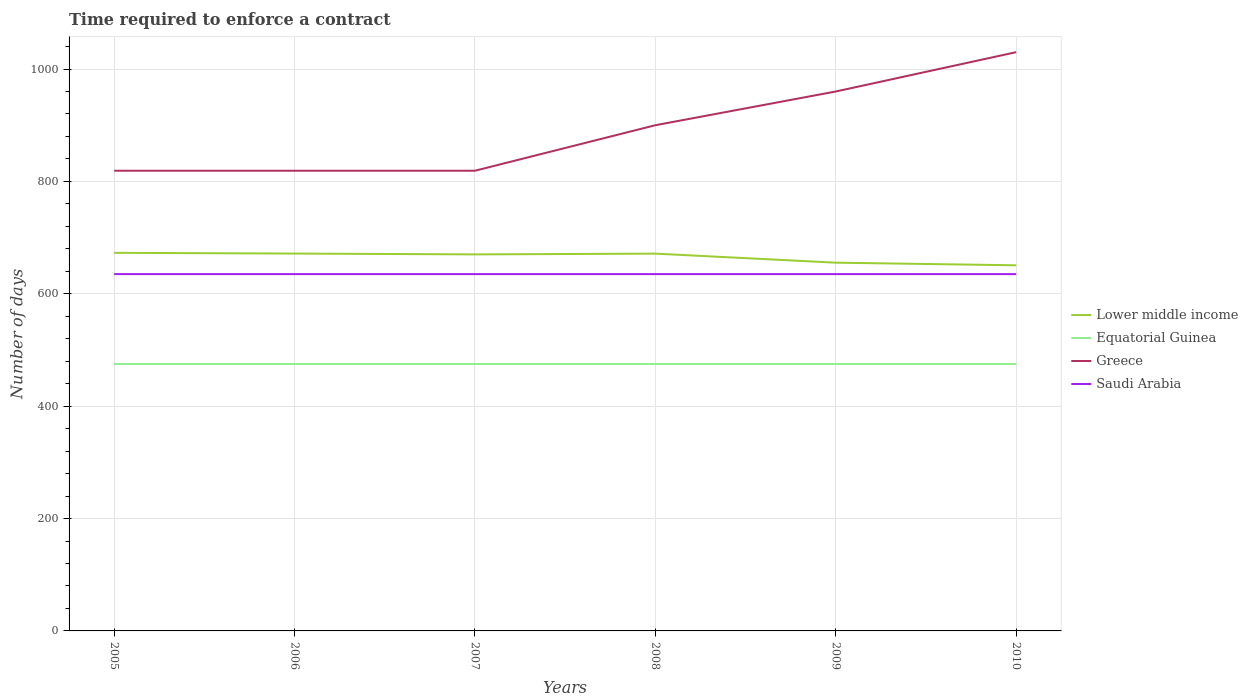Does the line corresponding to Equatorial Guinea intersect with the line corresponding to Lower middle income?
Your response must be concise. No. Is the number of lines equal to the number of legend labels?
Provide a succinct answer. Yes. Across all years, what is the maximum number of days required to enforce a contract in Saudi Arabia?
Ensure brevity in your answer.  635. In which year was the number of days required to enforce a contract in Saudi Arabia maximum?
Provide a short and direct response. 2005. What is the total number of days required to enforce a contract in Greece in the graph?
Your answer should be compact. -81. Is the number of days required to enforce a contract in Equatorial Guinea strictly greater than the number of days required to enforce a contract in Saudi Arabia over the years?
Offer a very short reply. Yes. How many lines are there?
Your answer should be very brief. 4. How many years are there in the graph?
Give a very brief answer. 6. Are the values on the major ticks of Y-axis written in scientific E-notation?
Your answer should be compact. No. Does the graph contain grids?
Provide a short and direct response. Yes. Where does the legend appear in the graph?
Make the answer very short. Center right. How many legend labels are there?
Ensure brevity in your answer.  4. How are the legend labels stacked?
Make the answer very short. Vertical. What is the title of the graph?
Your answer should be very brief. Time required to enforce a contract. What is the label or title of the Y-axis?
Give a very brief answer. Number of days. What is the Number of days of Lower middle income in 2005?
Provide a succinct answer. 672.89. What is the Number of days of Equatorial Guinea in 2005?
Keep it short and to the point. 475. What is the Number of days of Greece in 2005?
Your answer should be very brief. 819. What is the Number of days of Saudi Arabia in 2005?
Your answer should be compact. 635. What is the Number of days of Lower middle income in 2006?
Your answer should be compact. 671.59. What is the Number of days in Equatorial Guinea in 2006?
Offer a very short reply. 475. What is the Number of days in Greece in 2006?
Your response must be concise. 819. What is the Number of days in Saudi Arabia in 2006?
Offer a terse response. 635. What is the Number of days in Lower middle income in 2007?
Make the answer very short. 670.11. What is the Number of days in Equatorial Guinea in 2007?
Provide a succinct answer. 475. What is the Number of days of Greece in 2007?
Ensure brevity in your answer.  819. What is the Number of days in Saudi Arabia in 2007?
Provide a succinct answer. 635. What is the Number of days in Lower middle income in 2008?
Ensure brevity in your answer.  671.48. What is the Number of days in Equatorial Guinea in 2008?
Your answer should be very brief. 475. What is the Number of days in Greece in 2008?
Your response must be concise. 900. What is the Number of days of Saudi Arabia in 2008?
Make the answer very short. 635. What is the Number of days of Lower middle income in 2009?
Give a very brief answer. 655.36. What is the Number of days of Equatorial Guinea in 2009?
Your answer should be very brief. 475. What is the Number of days in Greece in 2009?
Offer a very short reply. 960. What is the Number of days of Saudi Arabia in 2009?
Give a very brief answer. 635. What is the Number of days of Lower middle income in 2010?
Keep it short and to the point. 650.69. What is the Number of days of Equatorial Guinea in 2010?
Your answer should be compact. 475. What is the Number of days of Greece in 2010?
Ensure brevity in your answer.  1030. What is the Number of days in Saudi Arabia in 2010?
Ensure brevity in your answer.  635. Across all years, what is the maximum Number of days of Lower middle income?
Make the answer very short. 672.89. Across all years, what is the maximum Number of days of Equatorial Guinea?
Ensure brevity in your answer.  475. Across all years, what is the maximum Number of days in Greece?
Ensure brevity in your answer.  1030. Across all years, what is the maximum Number of days of Saudi Arabia?
Your response must be concise. 635. Across all years, what is the minimum Number of days in Lower middle income?
Give a very brief answer. 650.69. Across all years, what is the minimum Number of days of Equatorial Guinea?
Offer a terse response. 475. Across all years, what is the minimum Number of days of Greece?
Your answer should be compact. 819. Across all years, what is the minimum Number of days in Saudi Arabia?
Ensure brevity in your answer.  635. What is the total Number of days of Lower middle income in the graph?
Your answer should be compact. 3992.11. What is the total Number of days in Equatorial Guinea in the graph?
Offer a terse response. 2850. What is the total Number of days in Greece in the graph?
Offer a very short reply. 5347. What is the total Number of days in Saudi Arabia in the graph?
Offer a very short reply. 3810. What is the difference between the Number of days of Lower middle income in 2005 and that in 2006?
Ensure brevity in your answer.  1.3. What is the difference between the Number of days in Equatorial Guinea in 2005 and that in 2006?
Your response must be concise. 0. What is the difference between the Number of days of Greece in 2005 and that in 2006?
Your response must be concise. 0. What is the difference between the Number of days of Saudi Arabia in 2005 and that in 2006?
Provide a succinct answer. 0. What is the difference between the Number of days in Lower middle income in 2005 and that in 2007?
Offer a very short reply. 2.77. What is the difference between the Number of days of Lower middle income in 2005 and that in 2008?
Keep it short and to the point. 1.41. What is the difference between the Number of days in Equatorial Guinea in 2005 and that in 2008?
Offer a very short reply. 0. What is the difference between the Number of days in Greece in 2005 and that in 2008?
Your answer should be very brief. -81. What is the difference between the Number of days of Saudi Arabia in 2005 and that in 2008?
Your response must be concise. 0. What is the difference between the Number of days in Lower middle income in 2005 and that in 2009?
Offer a very short reply. 17.53. What is the difference between the Number of days in Equatorial Guinea in 2005 and that in 2009?
Your response must be concise. 0. What is the difference between the Number of days in Greece in 2005 and that in 2009?
Offer a terse response. -141. What is the difference between the Number of days of Lower middle income in 2005 and that in 2010?
Your response must be concise. 22.2. What is the difference between the Number of days of Greece in 2005 and that in 2010?
Keep it short and to the point. -211. What is the difference between the Number of days in Saudi Arabia in 2005 and that in 2010?
Offer a terse response. 0. What is the difference between the Number of days in Lower middle income in 2006 and that in 2007?
Offer a terse response. 1.48. What is the difference between the Number of days of Greece in 2006 and that in 2007?
Make the answer very short. 0. What is the difference between the Number of days in Lower middle income in 2006 and that in 2008?
Keep it short and to the point. 0.11. What is the difference between the Number of days of Greece in 2006 and that in 2008?
Keep it short and to the point. -81. What is the difference between the Number of days in Saudi Arabia in 2006 and that in 2008?
Keep it short and to the point. 0. What is the difference between the Number of days in Lower middle income in 2006 and that in 2009?
Ensure brevity in your answer.  16.24. What is the difference between the Number of days in Greece in 2006 and that in 2009?
Make the answer very short. -141. What is the difference between the Number of days of Saudi Arabia in 2006 and that in 2009?
Ensure brevity in your answer.  0. What is the difference between the Number of days in Lower middle income in 2006 and that in 2010?
Give a very brief answer. 20.9. What is the difference between the Number of days of Equatorial Guinea in 2006 and that in 2010?
Ensure brevity in your answer.  0. What is the difference between the Number of days of Greece in 2006 and that in 2010?
Offer a very short reply. -211. What is the difference between the Number of days of Lower middle income in 2007 and that in 2008?
Your answer should be very brief. -1.36. What is the difference between the Number of days in Greece in 2007 and that in 2008?
Give a very brief answer. -81. What is the difference between the Number of days of Lower middle income in 2007 and that in 2009?
Give a very brief answer. 14.76. What is the difference between the Number of days in Greece in 2007 and that in 2009?
Your response must be concise. -141. What is the difference between the Number of days in Lower middle income in 2007 and that in 2010?
Make the answer very short. 19.42. What is the difference between the Number of days of Greece in 2007 and that in 2010?
Provide a succinct answer. -211. What is the difference between the Number of days in Saudi Arabia in 2007 and that in 2010?
Give a very brief answer. 0. What is the difference between the Number of days in Lower middle income in 2008 and that in 2009?
Your response must be concise. 16.12. What is the difference between the Number of days in Equatorial Guinea in 2008 and that in 2009?
Keep it short and to the point. 0. What is the difference between the Number of days of Greece in 2008 and that in 2009?
Your response must be concise. -60. What is the difference between the Number of days in Lower middle income in 2008 and that in 2010?
Your answer should be compact. 20.79. What is the difference between the Number of days of Equatorial Guinea in 2008 and that in 2010?
Your response must be concise. 0. What is the difference between the Number of days of Greece in 2008 and that in 2010?
Your response must be concise. -130. What is the difference between the Number of days of Lower middle income in 2009 and that in 2010?
Ensure brevity in your answer.  4.67. What is the difference between the Number of days of Greece in 2009 and that in 2010?
Provide a succinct answer. -70. What is the difference between the Number of days in Lower middle income in 2005 and the Number of days in Equatorial Guinea in 2006?
Make the answer very short. 197.89. What is the difference between the Number of days of Lower middle income in 2005 and the Number of days of Greece in 2006?
Make the answer very short. -146.11. What is the difference between the Number of days of Lower middle income in 2005 and the Number of days of Saudi Arabia in 2006?
Offer a very short reply. 37.89. What is the difference between the Number of days of Equatorial Guinea in 2005 and the Number of days of Greece in 2006?
Your answer should be compact. -344. What is the difference between the Number of days of Equatorial Guinea in 2005 and the Number of days of Saudi Arabia in 2006?
Offer a terse response. -160. What is the difference between the Number of days of Greece in 2005 and the Number of days of Saudi Arabia in 2006?
Give a very brief answer. 184. What is the difference between the Number of days in Lower middle income in 2005 and the Number of days in Equatorial Guinea in 2007?
Provide a succinct answer. 197.89. What is the difference between the Number of days in Lower middle income in 2005 and the Number of days in Greece in 2007?
Make the answer very short. -146.11. What is the difference between the Number of days of Lower middle income in 2005 and the Number of days of Saudi Arabia in 2007?
Your response must be concise. 37.89. What is the difference between the Number of days in Equatorial Guinea in 2005 and the Number of days in Greece in 2007?
Your answer should be very brief. -344. What is the difference between the Number of days in Equatorial Guinea in 2005 and the Number of days in Saudi Arabia in 2007?
Your answer should be very brief. -160. What is the difference between the Number of days of Greece in 2005 and the Number of days of Saudi Arabia in 2007?
Give a very brief answer. 184. What is the difference between the Number of days of Lower middle income in 2005 and the Number of days of Equatorial Guinea in 2008?
Ensure brevity in your answer.  197.89. What is the difference between the Number of days in Lower middle income in 2005 and the Number of days in Greece in 2008?
Your response must be concise. -227.11. What is the difference between the Number of days in Lower middle income in 2005 and the Number of days in Saudi Arabia in 2008?
Provide a succinct answer. 37.89. What is the difference between the Number of days of Equatorial Guinea in 2005 and the Number of days of Greece in 2008?
Ensure brevity in your answer.  -425. What is the difference between the Number of days in Equatorial Guinea in 2005 and the Number of days in Saudi Arabia in 2008?
Give a very brief answer. -160. What is the difference between the Number of days of Greece in 2005 and the Number of days of Saudi Arabia in 2008?
Your response must be concise. 184. What is the difference between the Number of days in Lower middle income in 2005 and the Number of days in Equatorial Guinea in 2009?
Your answer should be compact. 197.89. What is the difference between the Number of days of Lower middle income in 2005 and the Number of days of Greece in 2009?
Offer a terse response. -287.11. What is the difference between the Number of days in Lower middle income in 2005 and the Number of days in Saudi Arabia in 2009?
Offer a terse response. 37.89. What is the difference between the Number of days of Equatorial Guinea in 2005 and the Number of days of Greece in 2009?
Your response must be concise. -485. What is the difference between the Number of days in Equatorial Guinea in 2005 and the Number of days in Saudi Arabia in 2009?
Offer a terse response. -160. What is the difference between the Number of days in Greece in 2005 and the Number of days in Saudi Arabia in 2009?
Give a very brief answer. 184. What is the difference between the Number of days in Lower middle income in 2005 and the Number of days in Equatorial Guinea in 2010?
Offer a terse response. 197.89. What is the difference between the Number of days of Lower middle income in 2005 and the Number of days of Greece in 2010?
Offer a very short reply. -357.11. What is the difference between the Number of days in Lower middle income in 2005 and the Number of days in Saudi Arabia in 2010?
Your answer should be compact. 37.89. What is the difference between the Number of days of Equatorial Guinea in 2005 and the Number of days of Greece in 2010?
Keep it short and to the point. -555. What is the difference between the Number of days of Equatorial Guinea in 2005 and the Number of days of Saudi Arabia in 2010?
Your response must be concise. -160. What is the difference between the Number of days of Greece in 2005 and the Number of days of Saudi Arabia in 2010?
Provide a succinct answer. 184. What is the difference between the Number of days in Lower middle income in 2006 and the Number of days in Equatorial Guinea in 2007?
Provide a succinct answer. 196.59. What is the difference between the Number of days in Lower middle income in 2006 and the Number of days in Greece in 2007?
Offer a very short reply. -147.41. What is the difference between the Number of days of Lower middle income in 2006 and the Number of days of Saudi Arabia in 2007?
Make the answer very short. 36.59. What is the difference between the Number of days of Equatorial Guinea in 2006 and the Number of days of Greece in 2007?
Your answer should be very brief. -344. What is the difference between the Number of days in Equatorial Guinea in 2006 and the Number of days in Saudi Arabia in 2007?
Give a very brief answer. -160. What is the difference between the Number of days of Greece in 2006 and the Number of days of Saudi Arabia in 2007?
Your response must be concise. 184. What is the difference between the Number of days of Lower middle income in 2006 and the Number of days of Equatorial Guinea in 2008?
Ensure brevity in your answer.  196.59. What is the difference between the Number of days in Lower middle income in 2006 and the Number of days in Greece in 2008?
Provide a short and direct response. -228.41. What is the difference between the Number of days of Lower middle income in 2006 and the Number of days of Saudi Arabia in 2008?
Provide a succinct answer. 36.59. What is the difference between the Number of days in Equatorial Guinea in 2006 and the Number of days in Greece in 2008?
Your response must be concise. -425. What is the difference between the Number of days in Equatorial Guinea in 2006 and the Number of days in Saudi Arabia in 2008?
Offer a terse response. -160. What is the difference between the Number of days in Greece in 2006 and the Number of days in Saudi Arabia in 2008?
Keep it short and to the point. 184. What is the difference between the Number of days in Lower middle income in 2006 and the Number of days in Equatorial Guinea in 2009?
Offer a terse response. 196.59. What is the difference between the Number of days in Lower middle income in 2006 and the Number of days in Greece in 2009?
Your answer should be very brief. -288.41. What is the difference between the Number of days in Lower middle income in 2006 and the Number of days in Saudi Arabia in 2009?
Your response must be concise. 36.59. What is the difference between the Number of days in Equatorial Guinea in 2006 and the Number of days in Greece in 2009?
Your answer should be compact. -485. What is the difference between the Number of days in Equatorial Guinea in 2006 and the Number of days in Saudi Arabia in 2009?
Your response must be concise. -160. What is the difference between the Number of days in Greece in 2006 and the Number of days in Saudi Arabia in 2009?
Your answer should be compact. 184. What is the difference between the Number of days of Lower middle income in 2006 and the Number of days of Equatorial Guinea in 2010?
Ensure brevity in your answer.  196.59. What is the difference between the Number of days of Lower middle income in 2006 and the Number of days of Greece in 2010?
Offer a terse response. -358.41. What is the difference between the Number of days in Lower middle income in 2006 and the Number of days in Saudi Arabia in 2010?
Provide a short and direct response. 36.59. What is the difference between the Number of days of Equatorial Guinea in 2006 and the Number of days of Greece in 2010?
Provide a succinct answer. -555. What is the difference between the Number of days of Equatorial Guinea in 2006 and the Number of days of Saudi Arabia in 2010?
Give a very brief answer. -160. What is the difference between the Number of days in Greece in 2006 and the Number of days in Saudi Arabia in 2010?
Give a very brief answer. 184. What is the difference between the Number of days of Lower middle income in 2007 and the Number of days of Equatorial Guinea in 2008?
Offer a very short reply. 195.11. What is the difference between the Number of days in Lower middle income in 2007 and the Number of days in Greece in 2008?
Provide a succinct answer. -229.89. What is the difference between the Number of days of Lower middle income in 2007 and the Number of days of Saudi Arabia in 2008?
Give a very brief answer. 35.11. What is the difference between the Number of days in Equatorial Guinea in 2007 and the Number of days in Greece in 2008?
Make the answer very short. -425. What is the difference between the Number of days in Equatorial Guinea in 2007 and the Number of days in Saudi Arabia in 2008?
Provide a short and direct response. -160. What is the difference between the Number of days in Greece in 2007 and the Number of days in Saudi Arabia in 2008?
Your answer should be very brief. 184. What is the difference between the Number of days in Lower middle income in 2007 and the Number of days in Equatorial Guinea in 2009?
Your answer should be very brief. 195.11. What is the difference between the Number of days of Lower middle income in 2007 and the Number of days of Greece in 2009?
Keep it short and to the point. -289.89. What is the difference between the Number of days of Lower middle income in 2007 and the Number of days of Saudi Arabia in 2009?
Offer a very short reply. 35.11. What is the difference between the Number of days in Equatorial Guinea in 2007 and the Number of days in Greece in 2009?
Your response must be concise. -485. What is the difference between the Number of days in Equatorial Guinea in 2007 and the Number of days in Saudi Arabia in 2009?
Your response must be concise. -160. What is the difference between the Number of days in Greece in 2007 and the Number of days in Saudi Arabia in 2009?
Give a very brief answer. 184. What is the difference between the Number of days of Lower middle income in 2007 and the Number of days of Equatorial Guinea in 2010?
Offer a very short reply. 195.11. What is the difference between the Number of days of Lower middle income in 2007 and the Number of days of Greece in 2010?
Provide a succinct answer. -359.89. What is the difference between the Number of days of Lower middle income in 2007 and the Number of days of Saudi Arabia in 2010?
Give a very brief answer. 35.11. What is the difference between the Number of days in Equatorial Guinea in 2007 and the Number of days in Greece in 2010?
Provide a succinct answer. -555. What is the difference between the Number of days in Equatorial Guinea in 2007 and the Number of days in Saudi Arabia in 2010?
Ensure brevity in your answer.  -160. What is the difference between the Number of days in Greece in 2007 and the Number of days in Saudi Arabia in 2010?
Give a very brief answer. 184. What is the difference between the Number of days of Lower middle income in 2008 and the Number of days of Equatorial Guinea in 2009?
Offer a very short reply. 196.48. What is the difference between the Number of days of Lower middle income in 2008 and the Number of days of Greece in 2009?
Your response must be concise. -288.52. What is the difference between the Number of days in Lower middle income in 2008 and the Number of days in Saudi Arabia in 2009?
Provide a short and direct response. 36.48. What is the difference between the Number of days in Equatorial Guinea in 2008 and the Number of days in Greece in 2009?
Give a very brief answer. -485. What is the difference between the Number of days in Equatorial Guinea in 2008 and the Number of days in Saudi Arabia in 2009?
Offer a terse response. -160. What is the difference between the Number of days in Greece in 2008 and the Number of days in Saudi Arabia in 2009?
Provide a short and direct response. 265. What is the difference between the Number of days in Lower middle income in 2008 and the Number of days in Equatorial Guinea in 2010?
Ensure brevity in your answer.  196.48. What is the difference between the Number of days in Lower middle income in 2008 and the Number of days in Greece in 2010?
Your response must be concise. -358.52. What is the difference between the Number of days of Lower middle income in 2008 and the Number of days of Saudi Arabia in 2010?
Keep it short and to the point. 36.48. What is the difference between the Number of days in Equatorial Guinea in 2008 and the Number of days in Greece in 2010?
Give a very brief answer. -555. What is the difference between the Number of days of Equatorial Guinea in 2008 and the Number of days of Saudi Arabia in 2010?
Give a very brief answer. -160. What is the difference between the Number of days of Greece in 2008 and the Number of days of Saudi Arabia in 2010?
Give a very brief answer. 265. What is the difference between the Number of days of Lower middle income in 2009 and the Number of days of Equatorial Guinea in 2010?
Give a very brief answer. 180.36. What is the difference between the Number of days of Lower middle income in 2009 and the Number of days of Greece in 2010?
Ensure brevity in your answer.  -374.64. What is the difference between the Number of days in Lower middle income in 2009 and the Number of days in Saudi Arabia in 2010?
Provide a short and direct response. 20.36. What is the difference between the Number of days in Equatorial Guinea in 2009 and the Number of days in Greece in 2010?
Provide a succinct answer. -555. What is the difference between the Number of days in Equatorial Guinea in 2009 and the Number of days in Saudi Arabia in 2010?
Provide a succinct answer. -160. What is the difference between the Number of days in Greece in 2009 and the Number of days in Saudi Arabia in 2010?
Offer a terse response. 325. What is the average Number of days of Lower middle income per year?
Make the answer very short. 665.35. What is the average Number of days of Equatorial Guinea per year?
Provide a succinct answer. 475. What is the average Number of days of Greece per year?
Provide a short and direct response. 891.17. What is the average Number of days of Saudi Arabia per year?
Offer a terse response. 635. In the year 2005, what is the difference between the Number of days in Lower middle income and Number of days in Equatorial Guinea?
Give a very brief answer. 197.89. In the year 2005, what is the difference between the Number of days in Lower middle income and Number of days in Greece?
Provide a short and direct response. -146.11. In the year 2005, what is the difference between the Number of days in Lower middle income and Number of days in Saudi Arabia?
Your answer should be very brief. 37.89. In the year 2005, what is the difference between the Number of days in Equatorial Guinea and Number of days in Greece?
Your response must be concise. -344. In the year 2005, what is the difference between the Number of days in Equatorial Guinea and Number of days in Saudi Arabia?
Your answer should be compact. -160. In the year 2005, what is the difference between the Number of days of Greece and Number of days of Saudi Arabia?
Keep it short and to the point. 184. In the year 2006, what is the difference between the Number of days in Lower middle income and Number of days in Equatorial Guinea?
Keep it short and to the point. 196.59. In the year 2006, what is the difference between the Number of days in Lower middle income and Number of days in Greece?
Offer a very short reply. -147.41. In the year 2006, what is the difference between the Number of days in Lower middle income and Number of days in Saudi Arabia?
Keep it short and to the point. 36.59. In the year 2006, what is the difference between the Number of days of Equatorial Guinea and Number of days of Greece?
Your response must be concise. -344. In the year 2006, what is the difference between the Number of days of Equatorial Guinea and Number of days of Saudi Arabia?
Keep it short and to the point. -160. In the year 2006, what is the difference between the Number of days of Greece and Number of days of Saudi Arabia?
Your answer should be very brief. 184. In the year 2007, what is the difference between the Number of days of Lower middle income and Number of days of Equatorial Guinea?
Give a very brief answer. 195.11. In the year 2007, what is the difference between the Number of days in Lower middle income and Number of days in Greece?
Your response must be concise. -148.89. In the year 2007, what is the difference between the Number of days in Lower middle income and Number of days in Saudi Arabia?
Your response must be concise. 35.11. In the year 2007, what is the difference between the Number of days in Equatorial Guinea and Number of days in Greece?
Provide a succinct answer. -344. In the year 2007, what is the difference between the Number of days in Equatorial Guinea and Number of days in Saudi Arabia?
Keep it short and to the point. -160. In the year 2007, what is the difference between the Number of days of Greece and Number of days of Saudi Arabia?
Provide a succinct answer. 184. In the year 2008, what is the difference between the Number of days of Lower middle income and Number of days of Equatorial Guinea?
Provide a succinct answer. 196.48. In the year 2008, what is the difference between the Number of days of Lower middle income and Number of days of Greece?
Your response must be concise. -228.52. In the year 2008, what is the difference between the Number of days of Lower middle income and Number of days of Saudi Arabia?
Provide a succinct answer. 36.48. In the year 2008, what is the difference between the Number of days of Equatorial Guinea and Number of days of Greece?
Offer a terse response. -425. In the year 2008, what is the difference between the Number of days in Equatorial Guinea and Number of days in Saudi Arabia?
Provide a short and direct response. -160. In the year 2008, what is the difference between the Number of days of Greece and Number of days of Saudi Arabia?
Keep it short and to the point. 265. In the year 2009, what is the difference between the Number of days in Lower middle income and Number of days in Equatorial Guinea?
Your response must be concise. 180.36. In the year 2009, what is the difference between the Number of days in Lower middle income and Number of days in Greece?
Make the answer very short. -304.64. In the year 2009, what is the difference between the Number of days of Lower middle income and Number of days of Saudi Arabia?
Offer a very short reply. 20.36. In the year 2009, what is the difference between the Number of days of Equatorial Guinea and Number of days of Greece?
Your answer should be very brief. -485. In the year 2009, what is the difference between the Number of days in Equatorial Guinea and Number of days in Saudi Arabia?
Provide a succinct answer. -160. In the year 2009, what is the difference between the Number of days of Greece and Number of days of Saudi Arabia?
Offer a very short reply. 325. In the year 2010, what is the difference between the Number of days of Lower middle income and Number of days of Equatorial Guinea?
Offer a very short reply. 175.69. In the year 2010, what is the difference between the Number of days in Lower middle income and Number of days in Greece?
Ensure brevity in your answer.  -379.31. In the year 2010, what is the difference between the Number of days of Lower middle income and Number of days of Saudi Arabia?
Make the answer very short. 15.69. In the year 2010, what is the difference between the Number of days of Equatorial Guinea and Number of days of Greece?
Your answer should be compact. -555. In the year 2010, what is the difference between the Number of days in Equatorial Guinea and Number of days in Saudi Arabia?
Give a very brief answer. -160. In the year 2010, what is the difference between the Number of days in Greece and Number of days in Saudi Arabia?
Make the answer very short. 395. What is the ratio of the Number of days in Equatorial Guinea in 2005 to that in 2006?
Offer a very short reply. 1. What is the ratio of the Number of days in Lower middle income in 2005 to that in 2007?
Keep it short and to the point. 1. What is the ratio of the Number of days in Greece in 2005 to that in 2007?
Your response must be concise. 1. What is the ratio of the Number of days of Saudi Arabia in 2005 to that in 2007?
Ensure brevity in your answer.  1. What is the ratio of the Number of days of Lower middle income in 2005 to that in 2008?
Give a very brief answer. 1. What is the ratio of the Number of days in Greece in 2005 to that in 2008?
Give a very brief answer. 0.91. What is the ratio of the Number of days of Lower middle income in 2005 to that in 2009?
Your answer should be compact. 1.03. What is the ratio of the Number of days of Greece in 2005 to that in 2009?
Your response must be concise. 0.85. What is the ratio of the Number of days of Saudi Arabia in 2005 to that in 2009?
Provide a succinct answer. 1. What is the ratio of the Number of days of Lower middle income in 2005 to that in 2010?
Make the answer very short. 1.03. What is the ratio of the Number of days of Greece in 2005 to that in 2010?
Your response must be concise. 0.8. What is the ratio of the Number of days in Lower middle income in 2006 to that in 2007?
Give a very brief answer. 1. What is the ratio of the Number of days of Greece in 2006 to that in 2007?
Offer a terse response. 1. What is the ratio of the Number of days of Saudi Arabia in 2006 to that in 2007?
Offer a very short reply. 1. What is the ratio of the Number of days of Equatorial Guinea in 2006 to that in 2008?
Offer a terse response. 1. What is the ratio of the Number of days in Greece in 2006 to that in 2008?
Offer a terse response. 0.91. What is the ratio of the Number of days of Lower middle income in 2006 to that in 2009?
Ensure brevity in your answer.  1.02. What is the ratio of the Number of days in Equatorial Guinea in 2006 to that in 2009?
Provide a short and direct response. 1. What is the ratio of the Number of days in Greece in 2006 to that in 2009?
Give a very brief answer. 0.85. What is the ratio of the Number of days of Saudi Arabia in 2006 to that in 2009?
Keep it short and to the point. 1. What is the ratio of the Number of days of Lower middle income in 2006 to that in 2010?
Your answer should be very brief. 1.03. What is the ratio of the Number of days in Greece in 2006 to that in 2010?
Provide a succinct answer. 0.8. What is the ratio of the Number of days in Lower middle income in 2007 to that in 2008?
Provide a succinct answer. 1. What is the ratio of the Number of days of Greece in 2007 to that in 2008?
Keep it short and to the point. 0.91. What is the ratio of the Number of days of Saudi Arabia in 2007 to that in 2008?
Keep it short and to the point. 1. What is the ratio of the Number of days of Lower middle income in 2007 to that in 2009?
Ensure brevity in your answer.  1.02. What is the ratio of the Number of days of Equatorial Guinea in 2007 to that in 2009?
Make the answer very short. 1. What is the ratio of the Number of days in Greece in 2007 to that in 2009?
Your answer should be compact. 0.85. What is the ratio of the Number of days of Lower middle income in 2007 to that in 2010?
Ensure brevity in your answer.  1.03. What is the ratio of the Number of days of Greece in 2007 to that in 2010?
Offer a terse response. 0.8. What is the ratio of the Number of days in Saudi Arabia in 2007 to that in 2010?
Make the answer very short. 1. What is the ratio of the Number of days of Lower middle income in 2008 to that in 2009?
Offer a terse response. 1.02. What is the ratio of the Number of days of Greece in 2008 to that in 2009?
Your answer should be compact. 0.94. What is the ratio of the Number of days of Lower middle income in 2008 to that in 2010?
Ensure brevity in your answer.  1.03. What is the ratio of the Number of days of Equatorial Guinea in 2008 to that in 2010?
Keep it short and to the point. 1. What is the ratio of the Number of days of Greece in 2008 to that in 2010?
Your answer should be very brief. 0.87. What is the ratio of the Number of days in Equatorial Guinea in 2009 to that in 2010?
Offer a terse response. 1. What is the ratio of the Number of days of Greece in 2009 to that in 2010?
Your answer should be very brief. 0.93. What is the difference between the highest and the second highest Number of days of Lower middle income?
Your answer should be compact. 1.3. What is the difference between the highest and the lowest Number of days of Lower middle income?
Your answer should be very brief. 22.2. What is the difference between the highest and the lowest Number of days in Equatorial Guinea?
Keep it short and to the point. 0. What is the difference between the highest and the lowest Number of days in Greece?
Your response must be concise. 211. What is the difference between the highest and the lowest Number of days of Saudi Arabia?
Provide a succinct answer. 0. 